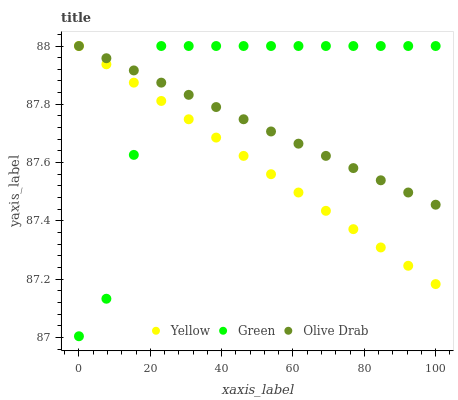Does Yellow have the minimum area under the curve?
Answer yes or no. Yes. Does Green have the maximum area under the curve?
Answer yes or no. Yes. Does Olive Drab have the minimum area under the curve?
Answer yes or no. No. Does Olive Drab have the maximum area under the curve?
Answer yes or no. No. Is Olive Drab the smoothest?
Answer yes or no. Yes. Is Green the roughest?
Answer yes or no. Yes. Is Yellow the smoothest?
Answer yes or no. No. Is Yellow the roughest?
Answer yes or no. No. Does Green have the lowest value?
Answer yes or no. Yes. Does Yellow have the lowest value?
Answer yes or no. No. Does Yellow have the highest value?
Answer yes or no. Yes. Does Yellow intersect Green?
Answer yes or no. Yes. Is Yellow less than Green?
Answer yes or no. No. Is Yellow greater than Green?
Answer yes or no. No. 